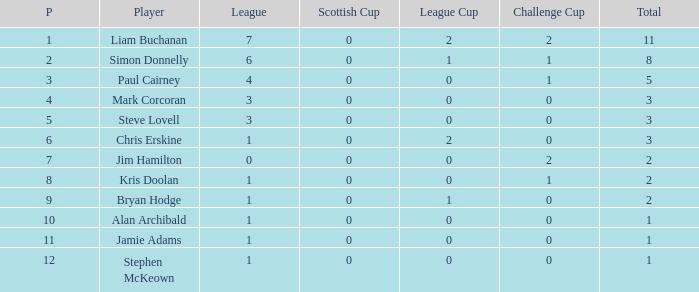What was the lowest number of points scored in the league cup? 0.0. 